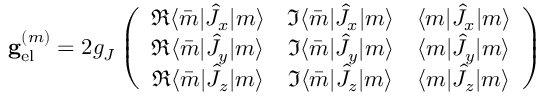Convert formula to latex. <formula><loc_0><loc_0><loc_500><loc_500>g _ { e l } ^ { ( m ) } = 2 g _ { J } \left ( \begin{array} { c c c } { \Re \langle \bar { m } | \hat { J } _ { x } | m \rangle } & { \Im \langle \bar { m } | \hat { J } _ { x } | m \rangle } & { \langle m | \hat { J } _ { x } | m \rangle } \\ { \Re \langle \bar { m } | \hat { J } _ { y } | m \rangle } & { \Im \langle \bar { m } | \hat { J } _ { y } | m \rangle } & { \langle m | \hat { J } _ { y } | m \rangle } \\ { \Re \langle \bar { m } | \hat { J } _ { z } | m \rangle } & { \Im \langle \bar { m } | \hat { J } _ { z } | m \rangle } & { \langle m | \hat { J } _ { z } | m \rangle } \end{array} \right )</formula> 